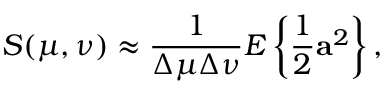<formula> <loc_0><loc_0><loc_500><loc_500>S ( \mu , \nu ) \approx \frac { 1 } { \Delta \mu \Delta \nu } E \left \{ \frac { 1 } { 2 } a ^ { 2 } \right \} ,</formula> 